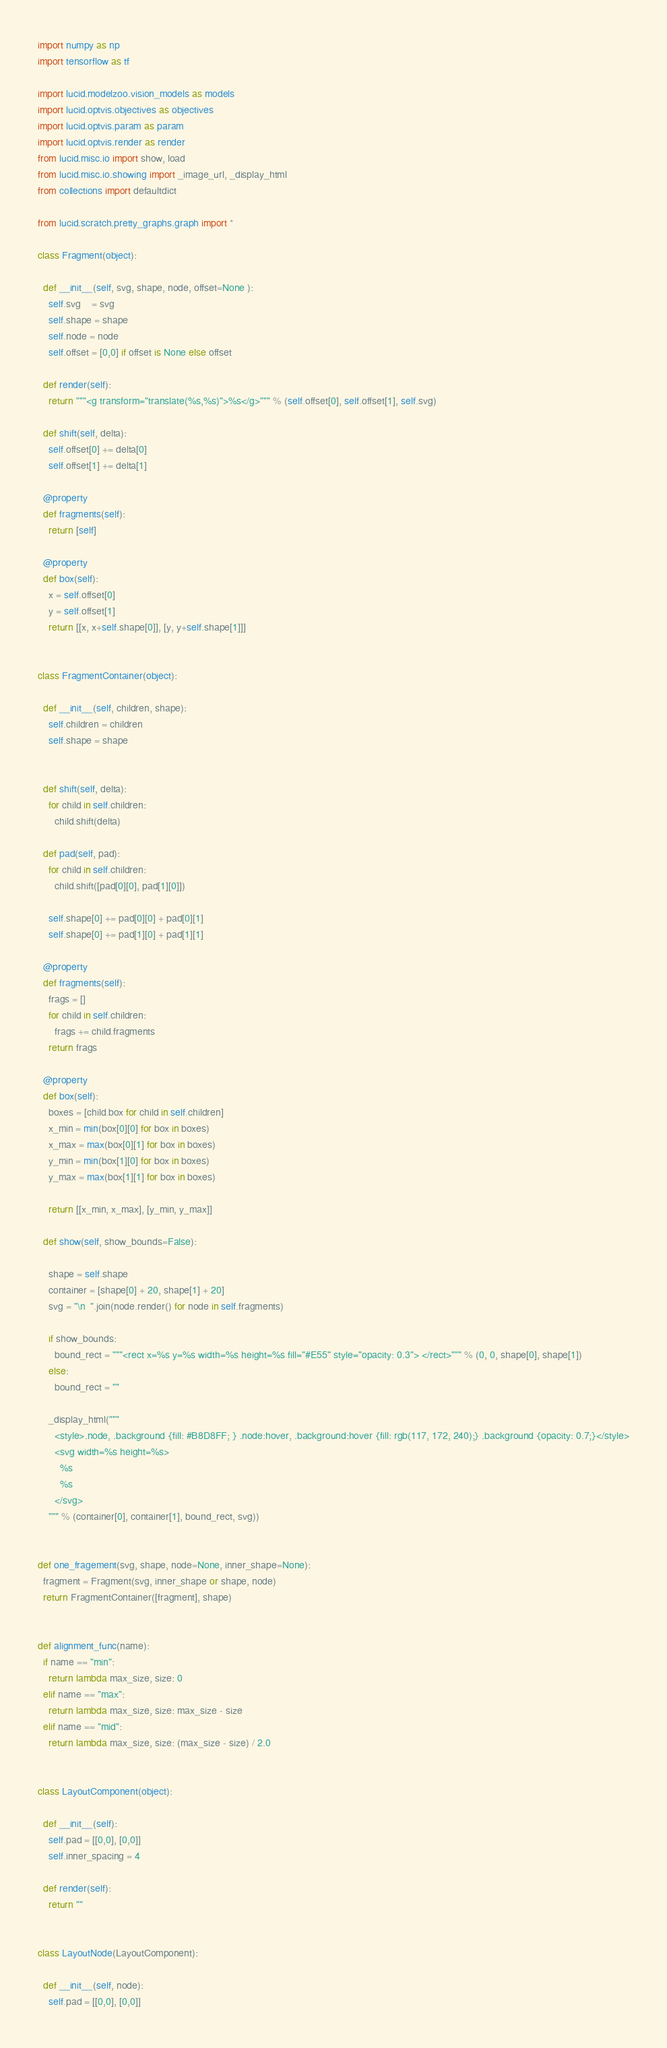<code> <loc_0><loc_0><loc_500><loc_500><_Python_>import numpy as np
import tensorflow as tf

import lucid.modelzoo.vision_models as models
import lucid.optvis.objectives as objectives
import lucid.optvis.param as param
import lucid.optvis.render as render
from lucid.misc.io import show, load
from lucid.misc.io.showing import _image_url, _display_html
from collections import defaultdict

from lucid.scratch.pretty_graphs.graph import *

class Fragment(object):

  def __init__(self, svg, shape, node, offset=None ):
    self.svg    = svg
    self.shape = shape
    self.node = node
    self.offset = [0,0] if offset is None else offset

  def render(self):
    return """<g transform="translate(%s,%s)">%s</g>""" % (self.offset[0], self.offset[1], self.svg)

  def shift(self, delta):
    self.offset[0] += delta[0]
    self.offset[1] += delta[1]

  @property
  def fragments(self):
    return [self]

  @property
  def box(self):
    x = self.offset[0]
    y = self.offset[1]
    return [[x, x+self.shape[0]], [y, y+self.shape[1]]]


class FragmentContainer(object):

  def __init__(self, children, shape):
    self.children = children
    self.shape = shape


  def shift(self, delta):
    for child in self.children:
      child.shift(delta)

  def pad(self, pad):
    for child in self.children:
      child.shift([pad[0][0], pad[1][0]])

    self.shape[0] += pad[0][0] + pad[0][1]
    self.shape[0] += pad[1][0] + pad[1][1]

  @property
  def fragments(self):
    frags = []
    for child in self.children:
      frags += child.fragments
    return frags

  @property
  def box(self):
    boxes = [child.box for child in self.children]
    x_min = min(box[0][0] for box in boxes)
    x_max = max(box[0][1] for box in boxes)
    y_min = min(box[1][0] for box in boxes)
    y_max = max(box[1][1] for box in boxes)

    return [[x_min, x_max], [y_min, y_max]]

  def show(self, show_bounds=False):

    shape = self.shape
    container = [shape[0] + 20, shape[1] + 20]
    svg = "\n  ".join(node.render() for node in self.fragments)

    if show_bounds:
      bound_rect = """<rect x=%s y=%s width=%s height=%s fill="#E55" style="opacity: 0.3"> </rect>""" % (0, 0, shape[0], shape[1])
    else:
      bound_rect = ""

    _display_html("""
      <style>.node, .background {fill: #B8D8FF; } .node:hover, .background:hover {fill: rgb(117, 172, 240);} .background {opacity: 0.7;}</style>
      <svg width=%s height=%s>
        %s
        %s
      </svg>
    """ % (container[0], container[1], bound_rect, svg))


def one_fragement(svg, shape, node=None, inner_shape=None):
  fragment = Fragment(svg, inner_shape or shape, node)
  return FragmentContainer([fragment], shape)


def alignment_func(name):
  if name == "min":
    return lambda max_size, size: 0
  elif name == "max":
    return lambda max_size, size: max_size - size
  elif name == "mid":
    return lambda max_size, size: (max_size - size) / 2.0


class LayoutComponent(object):

  def __init__(self):
    self.pad = [[0,0], [0,0]]
    self.inner_spacing = 4

  def render(self):
    return ""


class LayoutNode(LayoutComponent):

  def __init__(self, node):
    self.pad = [[0,0], [0,0]]</code> 